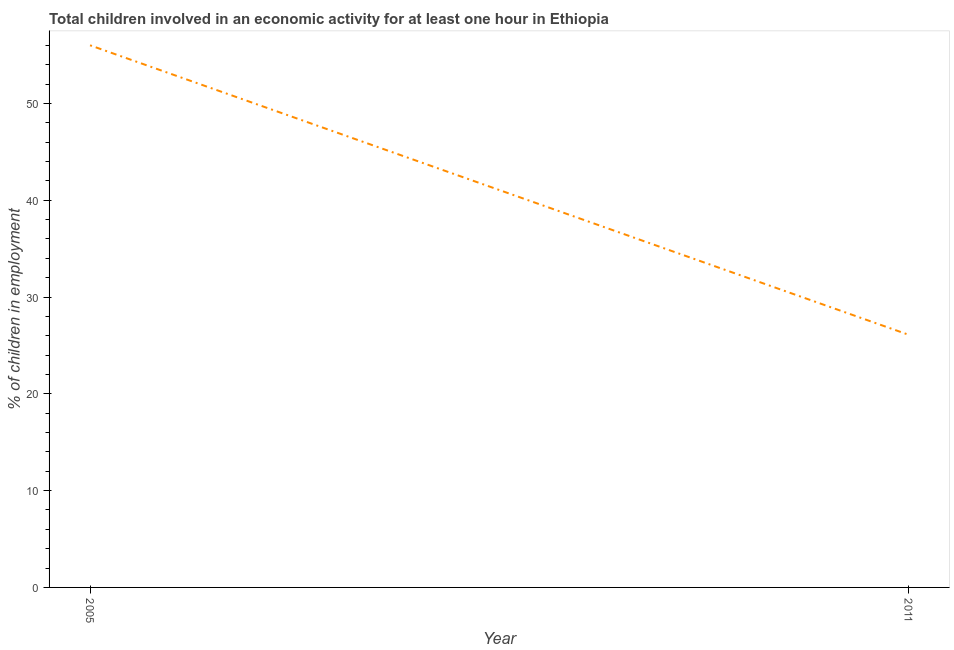What is the percentage of children in employment in 2005?
Keep it short and to the point. 56. Across all years, what is the maximum percentage of children in employment?
Give a very brief answer. 56. Across all years, what is the minimum percentage of children in employment?
Ensure brevity in your answer.  26.1. In which year was the percentage of children in employment maximum?
Ensure brevity in your answer.  2005. What is the sum of the percentage of children in employment?
Ensure brevity in your answer.  82.1. What is the difference between the percentage of children in employment in 2005 and 2011?
Keep it short and to the point. 29.9. What is the average percentage of children in employment per year?
Give a very brief answer. 41.05. What is the median percentage of children in employment?
Your answer should be very brief. 41.05. In how many years, is the percentage of children in employment greater than 12 %?
Your answer should be compact. 2. What is the ratio of the percentage of children in employment in 2005 to that in 2011?
Ensure brevity in your answer.  2.15. Is the percentage of children in employment in 2005 less than that in 2011?
Give a very brief answer. No. Does the percentage of children in employment monotonically increase over the years?
Ensure brevity in your answer.  No. How many years are there in the graph?
Your answer should be compact. 2. What is the difference between two consecutive major ticks on the Y-axis?
Provide a succinct answer. 10. Are the values on the major ticks of Y-axis written in scientific E-notation?
Provide a short and direct response. No. Does the graph contain grids?
Ensure brevity in your answer.  No. What is the title of the graph?
Make the answer very short. Total children involved in an economic activity for at least one hour in Ethiopia. What is the label or title of the Y-axis?
Your answer should be compact. % of children in employment. What is the % of children in employment in 2011?
Offer a terse response. 26.1. What is the difference between the % of children in employment in 2005 and 2011?
Provide a succinct answer. 29.9. What is the ratio of the % of children in employment in 2005 to that in 2011?
Your answer should be compact. 2.15. 